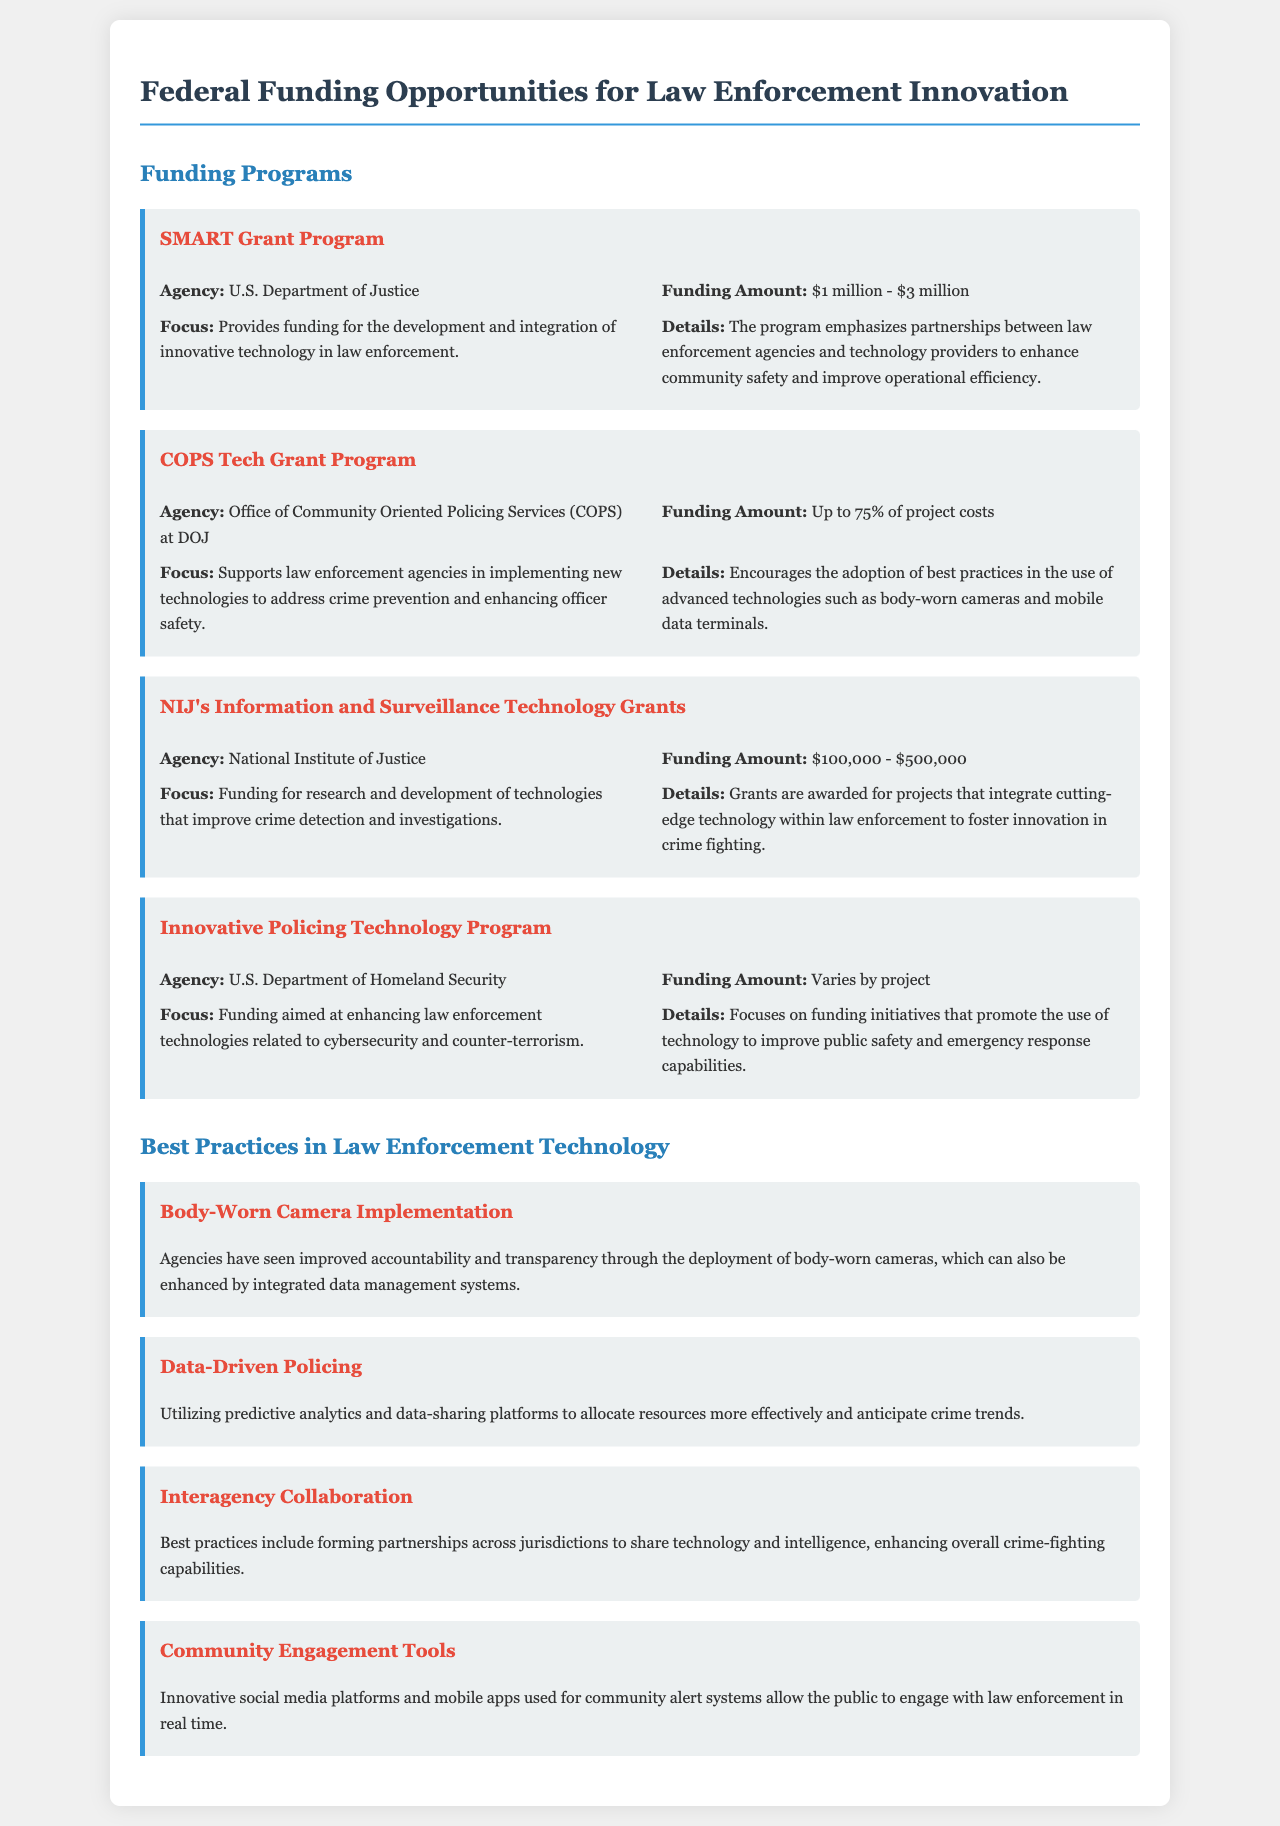What is the funding amount for the SMART Grant Program? The funding amount for the SMART Grant Program ranges from $1 million to $3 million.
Answer: $1 million - $3 million Which agency administers the COPS Tech Grant Program? The COPS Tech Grant Program is administered by the Office of Community Oriented Policing Services (COPS) at the DOJ.
Answer: Office of Community Oriented Policing Services (COPS) at DOJ What is a focus area of the NIJ's Information and Surveillance Technology Grants? A focus area of these grants is the research and development of technologies that improve crime detection and investigations.
Answer: Crime detection and investigations What percentage of project costs can the COPS Tech Grant Program cover? The COPS Tech Grant Program can cover up to 75% of project costs.
Answer: Up to 75% What is one best practice mentioned for law enforcement technology? One best practice mentioned is Data-Driven Policing, which utilizes predictive analytics and data-sharing platforms.
Answer: Data-Driven Policing What is the funding aim of the Innovative Policing Technology Program? The funding aim of the Innovative Policing Technology Program is to enhance law enforcement technologies related to cybersecurity and counter-terrorism.
Answer: Cybersecurity and counter-terrorism What type of funding does the U.S. Department of Homeland Security provide through the Innovative Policing Technology Program? The funding varies by project in the Innovative Policing Technology Program.
Answer: Varies by project What is an example of a tool used for community engagement mentioned in the document? Innovative social media platforms and mobile apps are mentioned as tools for community engagement.
Answer: Social media platforms and mobile apps 